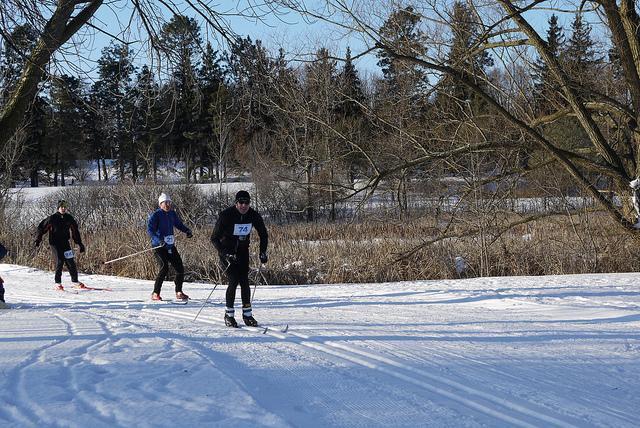How many skiers are in the picture?
Give a very brief answer. 3. How many people are visible?
Give a very brief answer. 3. 